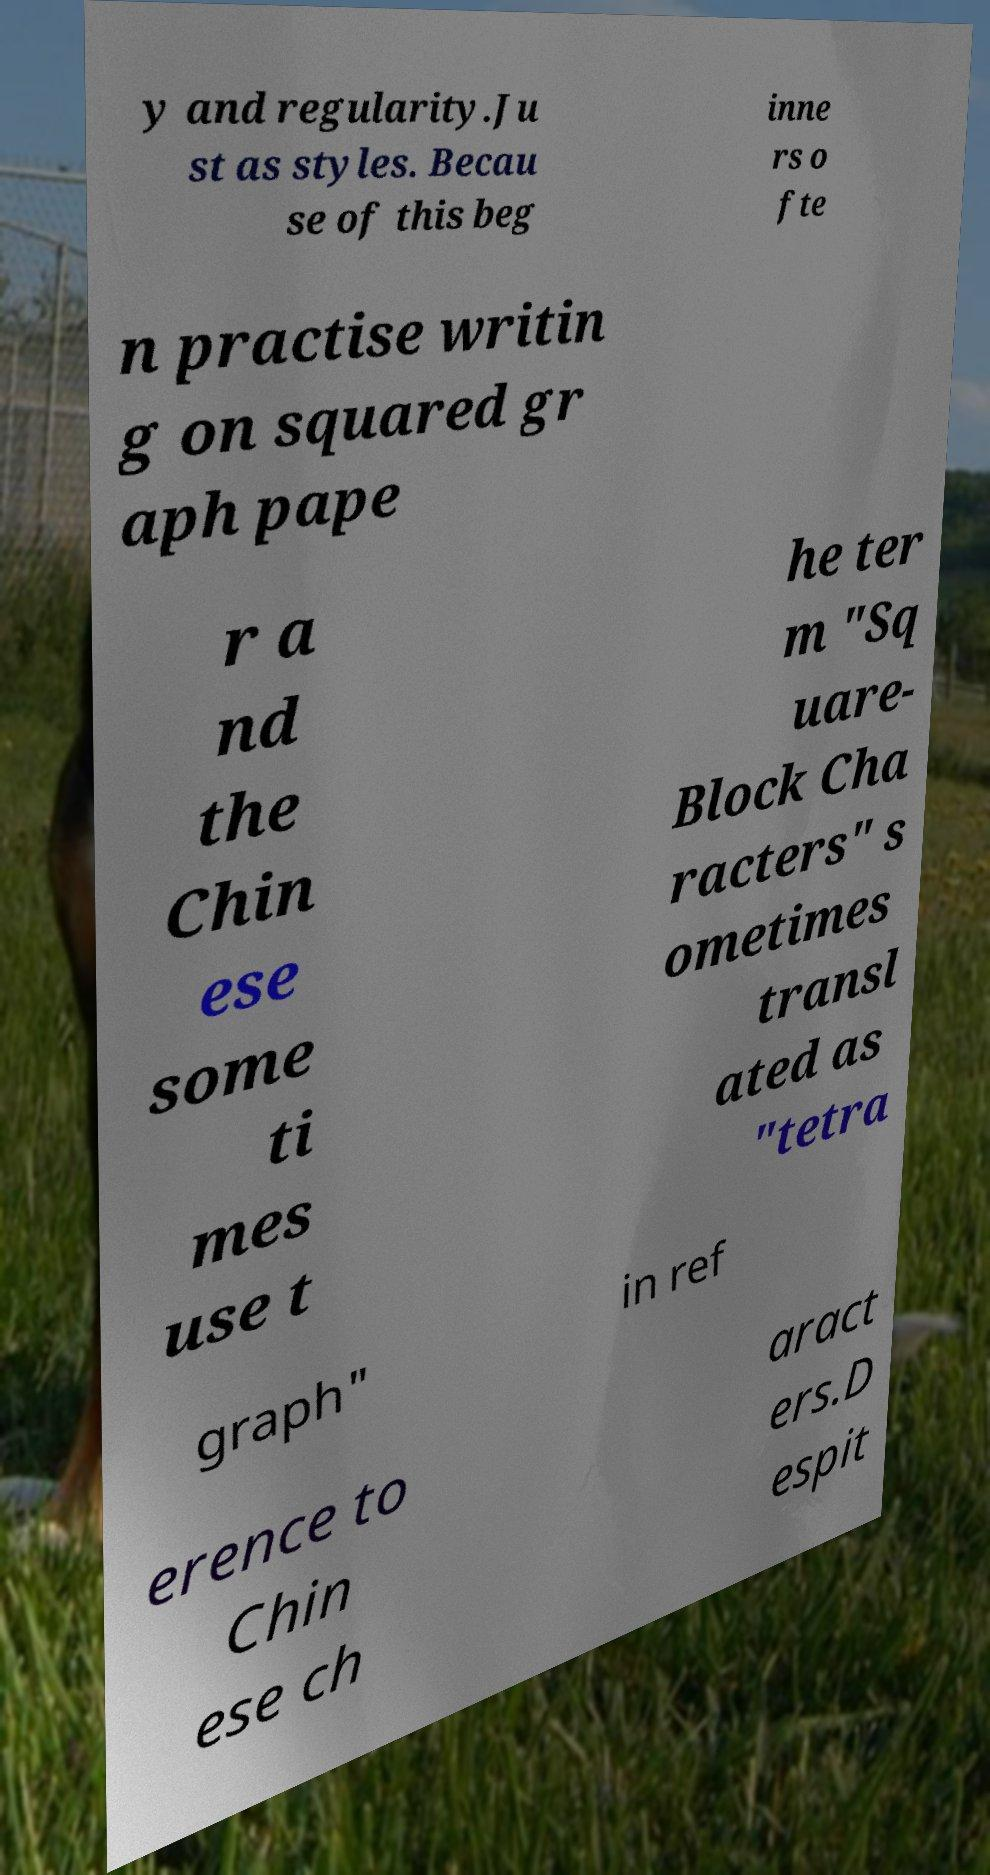Can you read and provide the text displayed in the image?This photo seems to have some interesting text. Can you extract and type it out for me? y and regularity.Ju st as styles. Becau se of this beg inne rs o fte n practise writin g on squared gr aph pape r a nd the Chin ese some ti mes use t he ter m "Sq uare- Block Cha racters" s ometimes transl ated as "tetra graph" in ref erence to Chin ese ch aract ers.D espit 